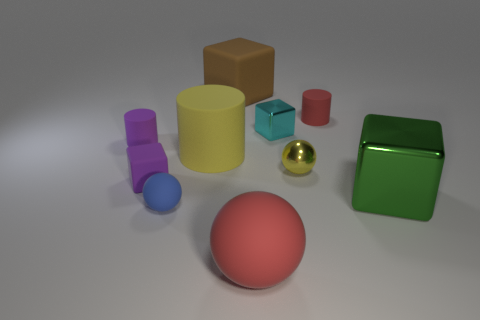Is the number of tiny yellow metal objects that are in front of the tiny purple block greater than the number of small purple cylinders to the right of the large matte cylinder?
Offer a very short reply. No. There is a large red object that is made of the same material as the tiny blue thing; what shape is it?
Give a very brief answer. Sphere. What number of other things are there of the same shape as the large brown object?
Make the answer very short. 3. What shape is the tiny metallic object that is in front of the large yellow object?
Your answer should be very brief. Sphere. The big matte sphere has what color?
Provide a succinct answer. Red. How many other things are there of the same size as the brown rubber thing?
Your response must be concise. 3. What is the material of the large cylinder to the left of the small ball behind the large shiny block?
Keep it short and to the point. Rubber. Do the purple cube and the red object that is behind the tiny purple cube have the same size?
Your response must be concise. Yes. Is there a big metal block of the same color as the small matte ball?
Make the answer very short. No. How many tiny objects are either rubber objects or purple rubber objects?
Your response must be concise. 4. 